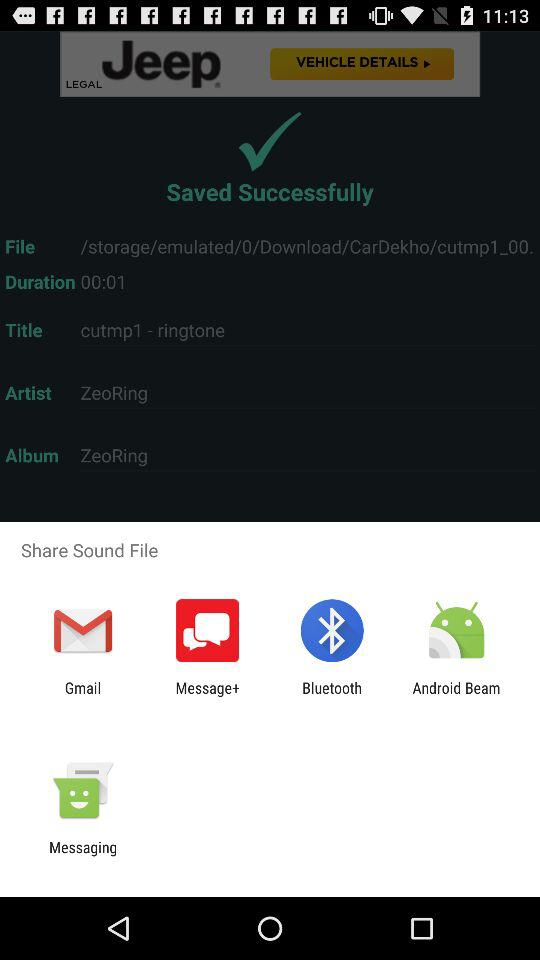Who is sharing the sound file?
When the provided information is insufficient, respond with <no answer>. <no answer> 